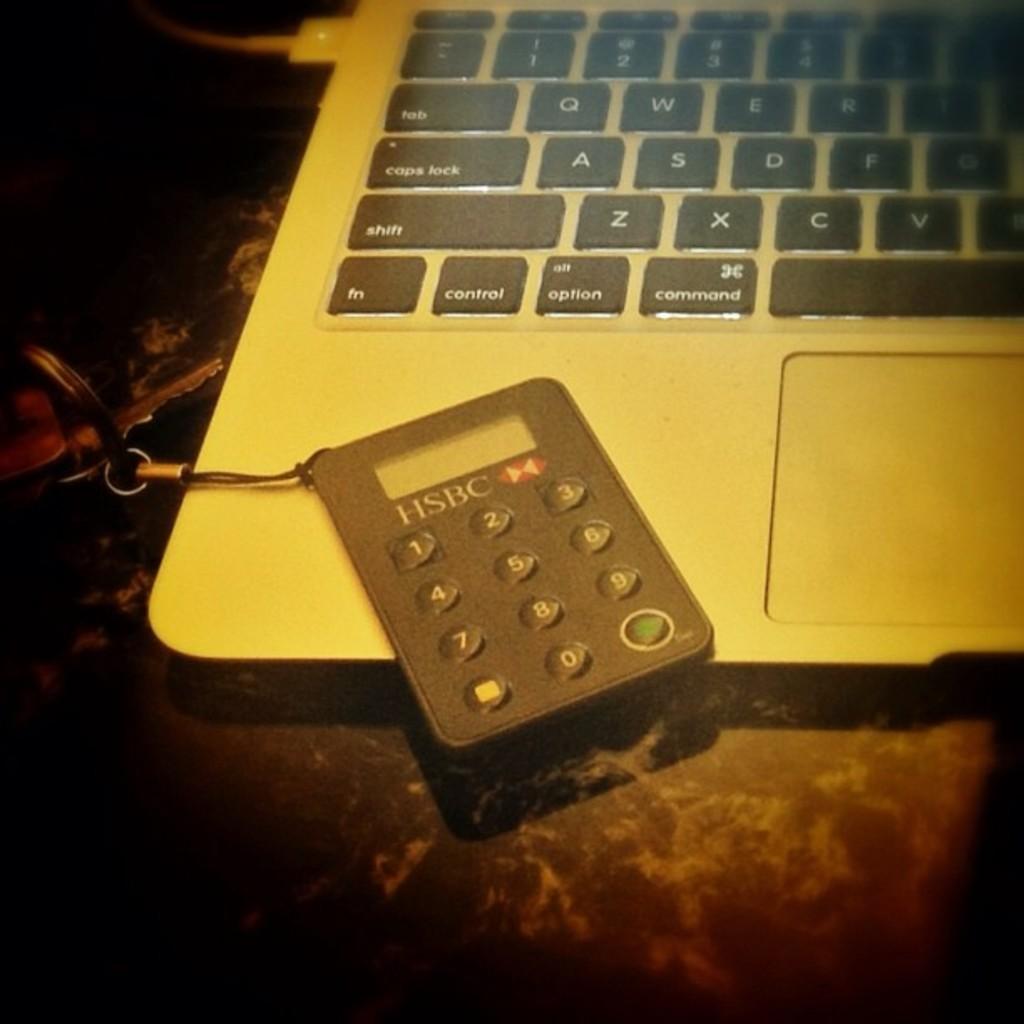What bank is this calculator from?
Your answer should be compact. Hsbc. What key is to the left of the spacebar?
Your response must be concise. Command. 